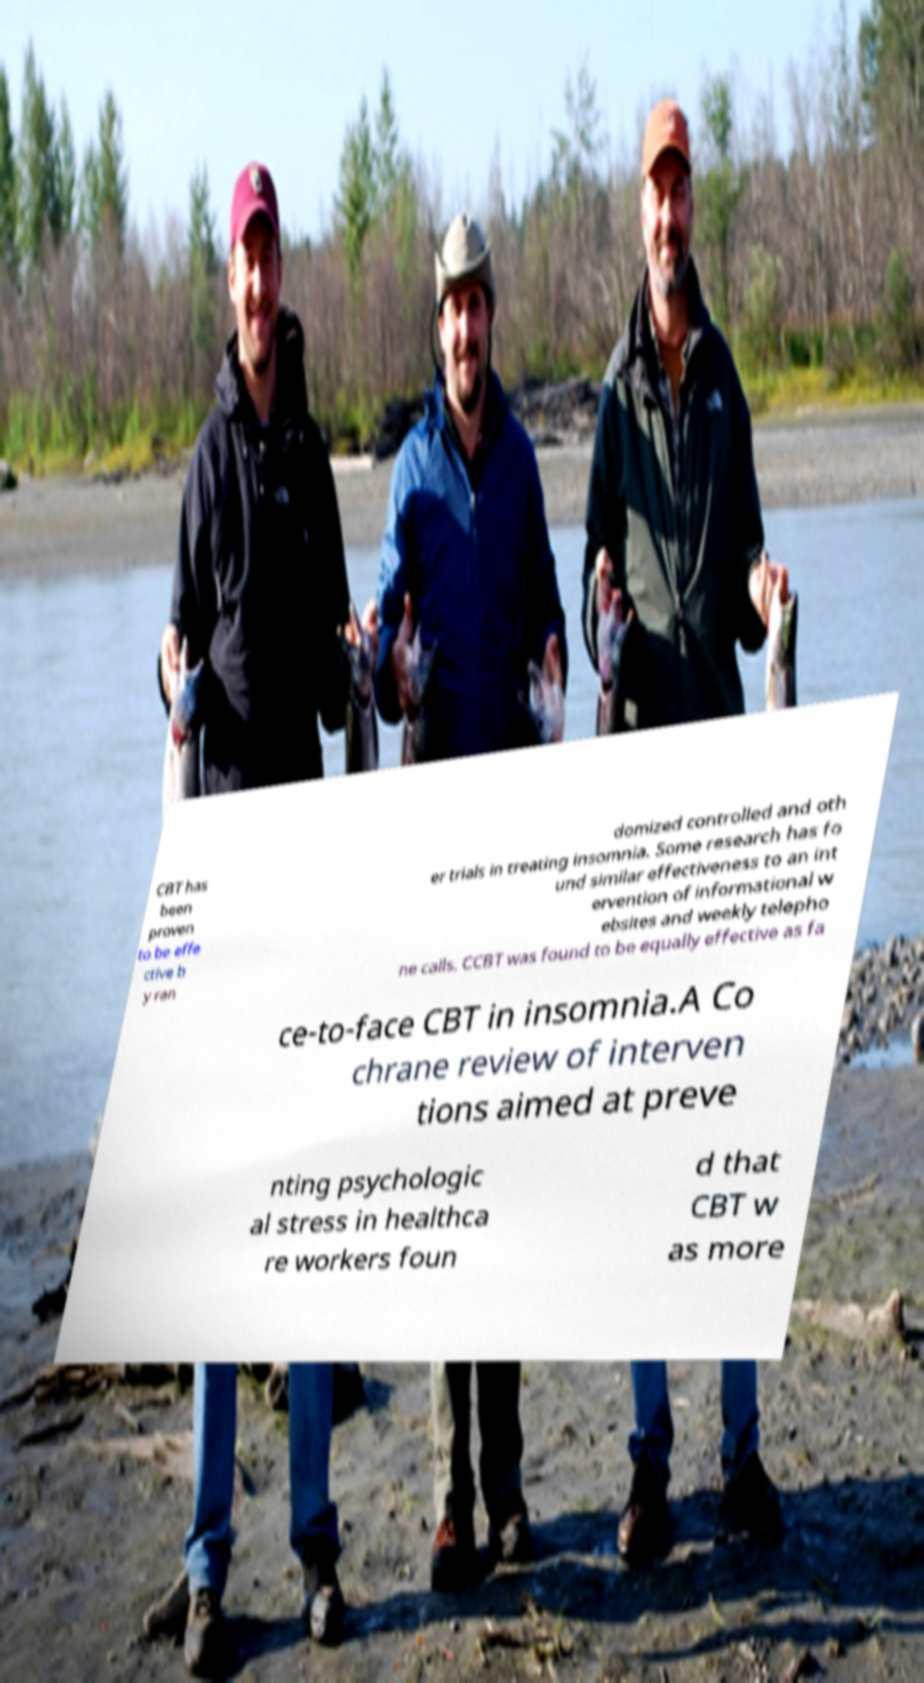Could you assist in decoding the text presented in this image and type it out clearly? CBT has been proven to be effe ctive b y ran domized controlled and oth er trials in treating insomnia. Some research has fo und similar effectiveness to an int ervention of informational w ebsites and weekly telepho ne calls. CCBT was found to be equally effective as fa ce-to-face CBT in insomnia.A Co chrane review of interven tions aimed at preve nting psychologic al stress in healthca re workers foun d that CBT w as more 